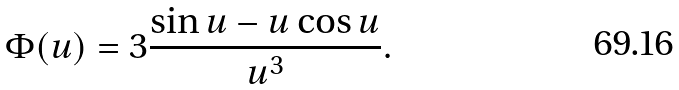Convert formula to latex. <formula><loc_0><loc_0><loc_500><loc_500>\Phi ( u ) = 3 \frac { \sin u - u \cos u } { u ^ { 3 } } .</formula> 